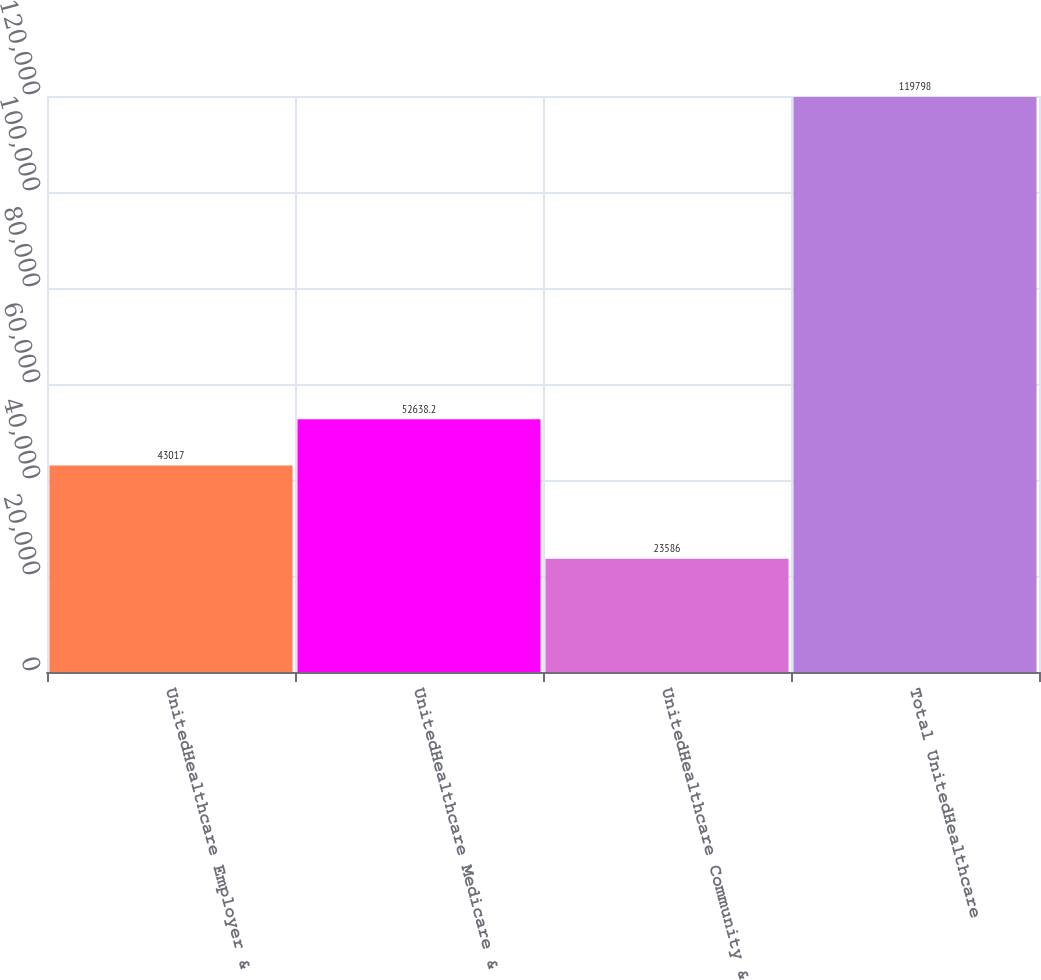Convert chart. <chart><loc_0><loc_0><loc_500><loc_500><bar_chart><fcel>UnitedHealthcare Employer &<fcel>UnitedHealthcare Medicare &<fcel>UnitedHealthcare Community &<fcel>Total UnitedHealthcare<nl><fcel>43017<fcel>52638.2<fcel>23586<fcel>119798<nl></chart> 